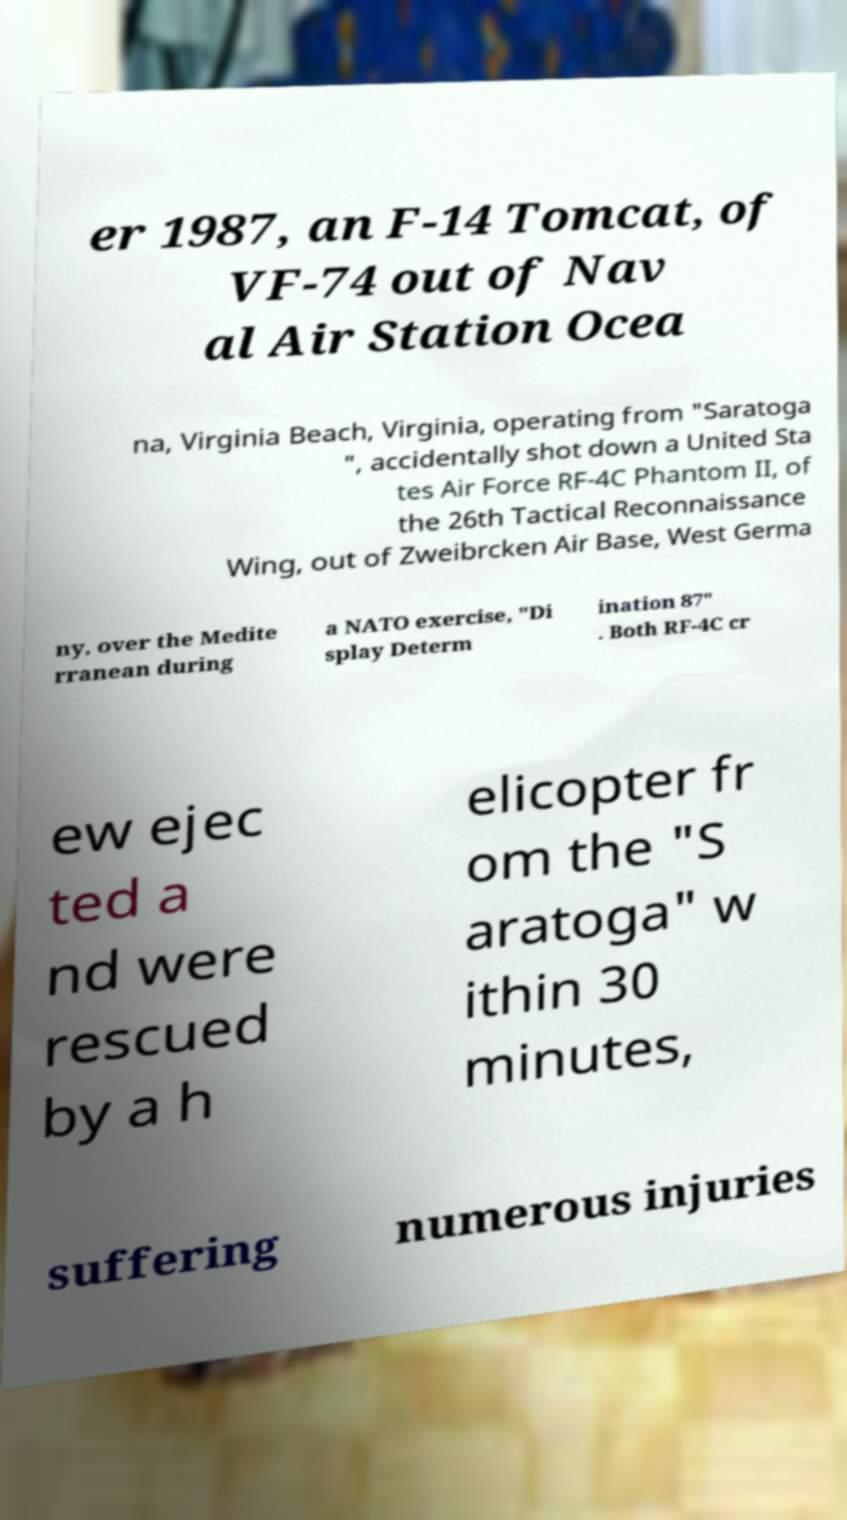What messages or text are displayed in this image? I need them in a readable, typed format. er 1987, an F-14 Tomcat, of VF-74 out of Nav al Air Station Ocea na, Virginia Beach, Virginia, operating from "Saratoga ", accidentally shot down a United Sta tes Air Force RF-4C Phantom II, of the 26th Tactical Reconnaissance Wing, out of Zweibrcken Air Base, West Germa ny, over the Medite rranean during a NATO exercise, "Di splay Determ ination 87" . Both RF-4C cr ew ejec ted a nd were rescued by a h elicopter fr om the "S aratoga" w ithin 30 minutes, suffering numerous injuries 